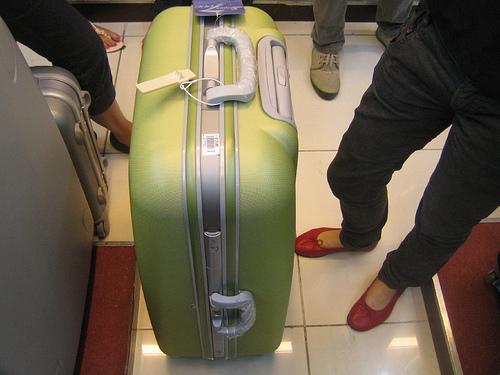What color are the floor tiles?
Concise answer only. White. What recent decade was this color of suitcase popular?
Write a very short answer. 70's. Is the person with the red shoes wearing high heels?
Be succinct. No. 